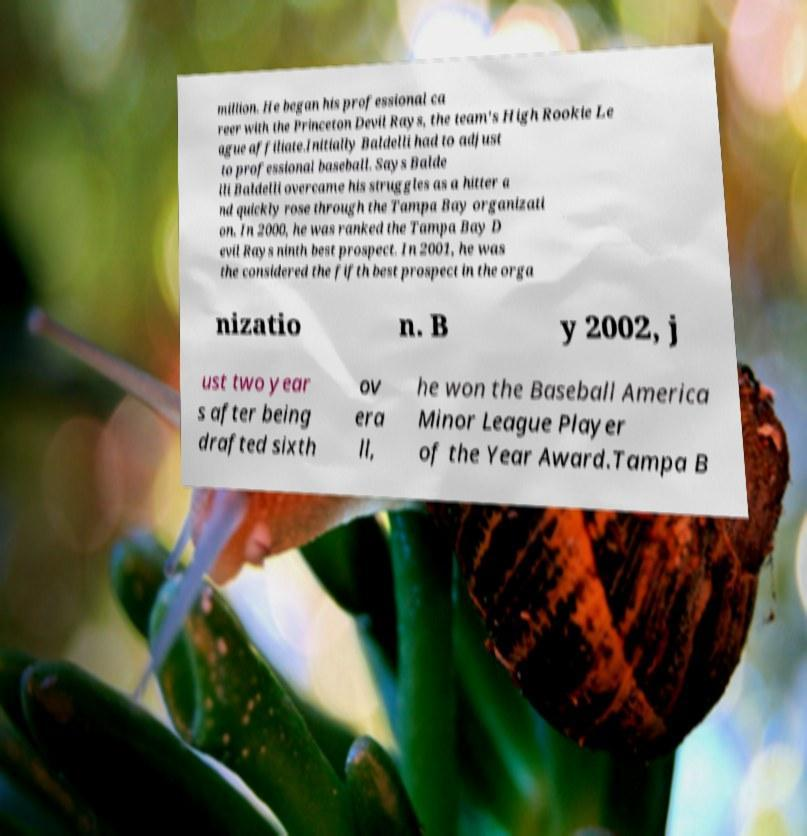What messages or text are displayed in this image? I need them in a readable, typed format. million. He began his professional ca reer with the Princeton Devil Rays, the team's High Rookie Le ague affiliate.Initially Baldelli had to adjust to professional baseball. Says Balde lli Baldelli overcame his struggles as a hitter a nd quickly rose through the Tampa Bay organizati on. In 2000, he was ranked the Tampa Bay D evil Rays ninth best prospect. In 2001, he was the considered the fifth best prospect in the orga nizatio n. B y 2002, j ust two year s after being drafted sixth ov era ll, he won the Baseball America Minor League Player of the Year Award.Tampa B 